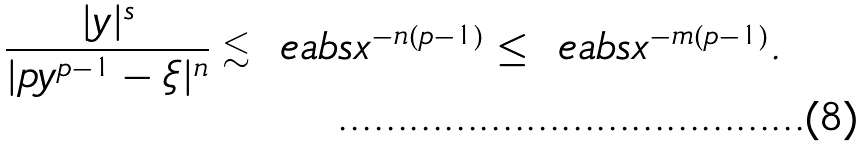<formula> <loc_0><loc_0><loc_500><loc_500>\frac { | y | ^ { s } } { | p y ^ { p - 1 } - \xi | ^ { n } } \lesssim \ e a b s { x } ^ { - n ( p - 1 ) } \leq \ e a b s { x } ^ { - m ( p - 1 ) } .</formula> 